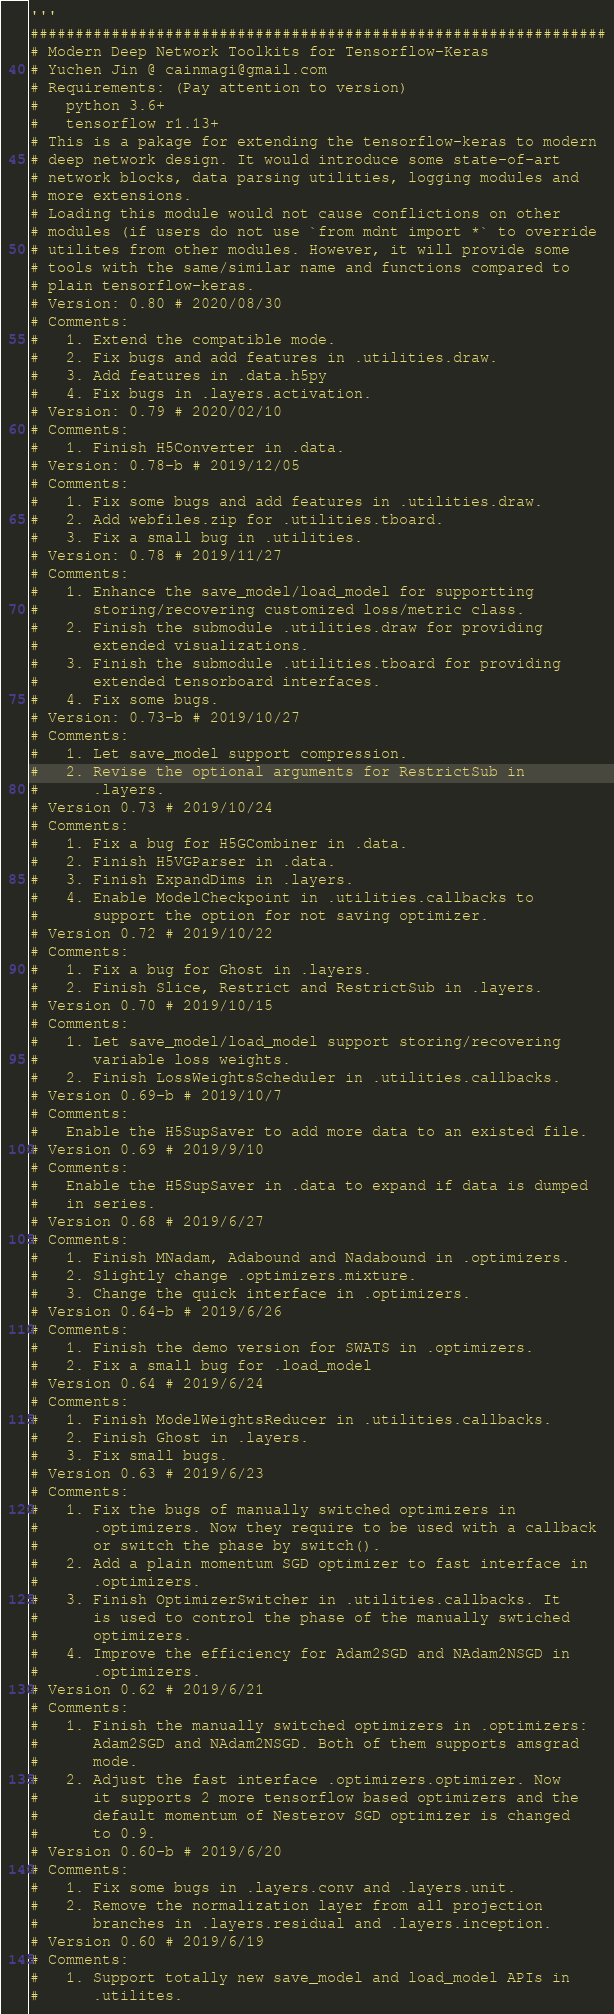<code> <loc_0><loc_0><loc_500><loc_500><_Python_>'''
################################################################
# Modern Deep Network Toolkits for Tensorflow-Keras
# Yuchen Jin @ cainmagi@gmail.com
# Requirements: (Pay attention to version)
#   python 3.6+
#   tensorflow r1.13+
# This is a pakage for extending the tensorflow-keras to modern
# deep network design. It would introduce some state-of-art
# network blocks, data parsing utilities, logging modules and
# more extensions.
# Loading this module would not cause conflictions on other
# modules (if users do not use `from mdnt import *` to override
# utilites from other modules. However, it will provide some
# tools with the same/similar name and functions compared to
# plain tensorflow-keras.
# Version: 0.80 # 2020/08/30
# Comments:
#   1. Extend the compatible mode.
#   2. Fix bugs and add features in .utilities.draw.
#   3. Add features in .data.h5py
#   4. Fix bugs in .layers.activation.
# Version: 0.79 # 2020/02/10
# Comments:
#   1. Finish H5Converter in .data.
# Version: 0.78-b # 2019/12/05
# Comments:
#   1. Fix some bugs and add features in .utilities.draw.
#   2. Add webfiles.zip for .utilities.tboard.
#   3. Fix a small bug in .utilities.
# Version: 0.78 # 2019/11/27
# Comments:
#   1. Enhance the save_model/load_model for supportting
#      storing/recovering customized loss/metric class.
#   2. Finish the submodule .utilities.draw for providing
#      extended visualizations.
#   3. Finish the submodule .utilities.tboard for providing
#      extended tensorboard interfaces.
#   4. Fix some bugs.
# Version: 0.73-b # 2019/10/27
# Comments:
#   1. Let save_model support compression.
#   2. Revise the optional arguments for RestrictSub in
#      .layers.
# Version 0.73 # 2019/10/24
# Comments:
#   1. Fix a bug for H5GCombiner in .data.
#   2. Finish H5VGParser in .data.
#   3. Finish ExpandDims in .layers.
#   4. Enable ModelCheckpoint in .utilities.callbacks to
#      support the option for not saving optimizer.
# Version 0.72 # 2019/10/22
# Comments:
#   1. Fix a bug for Ghost in .layers.
#   2. Finish Slice, Restrict and RestrictSub in .layers.
# Version 0.70 # 2019/10/15
# Comments:
#   1. Let save_model/load_model support storing/recovering
#      variable loss weights.
#   2. Finish LossWeightsScheduler in .utilities.callbacks.
# Version 0.69-b # 2019/10/7
# Comments:
#   Enable the H5SupSaver to add more data to an existed file.
# Version 0.69 # 2019/9/10
# Comments:
#   Enable the H5SupSaver in .data to expand if data is dumped
#   in series.
# Version 0.68 # 2019/6/27
# Comments:
#   1. Finish MNadam, Adabound and Nadabound in .optimizers.
#   2. Slightly change .optimizers.mixture.
#   3. Change the quick interface in .optimizers.
# Version 0.64-b # 2019/6/26
# Comments:
#   1. Finish the demo version for SWATS in .optimizers.
#   2. Fix a small bug for .load_model
# Version 0.64 # 2019/6/24
# Comments:
#   1. Finish ModelWeightsReducer in .utilities.callbacks.
#   2. Finish Ghost in .layers.
#   3. Fix small bugs.
# Version 0.63 # 2019/6/23
# Comments:
#   1. Fix the bugs of manually switched optimizers in 
#      .optimizers. Now they require to be used with a callback
#      or switch the phase by switch().
#   2. Add a plain momentum SGD optimizer to fast interface in
#      .optimizers.
#   3. Finish OptimizerSwitcher in .utilities.callbacks. It
#      is used to control the phase of the manually swtiched
#      optimizers.
#   4. Improve the efficiency for Adam2SGD and NAdam2NSGD in
#      .optimizers.
# Version 0.62 # 2019/6/21
# Comments:
#   1. Finish the manually switched optimizers in .optimizers:
#      Adam2SGD and NAdam2NSGD. Both of them supports amsgrad
#      mode.
#   2. Adjust the fast interface .optimizers.optimizer. Now
#      it supports 2 more tensorflow based optimizers and the
#      default momentum of Nesterov SGD optimizer is changed
#      to 0.9.
# Version 0.60-b # 2019/6/20
# Comments:
#   1. Fix some bugs in .layers.conv and .layers.unit.
#   2. Remove the normalization layer from all projection 
#      branches in .layers.residual and .layers.inception.
# Version 0.60 # 2019/6/19
# Comments:
#   1. Support totally new save_model and load_model APIs in
#      .utilites.</code> 